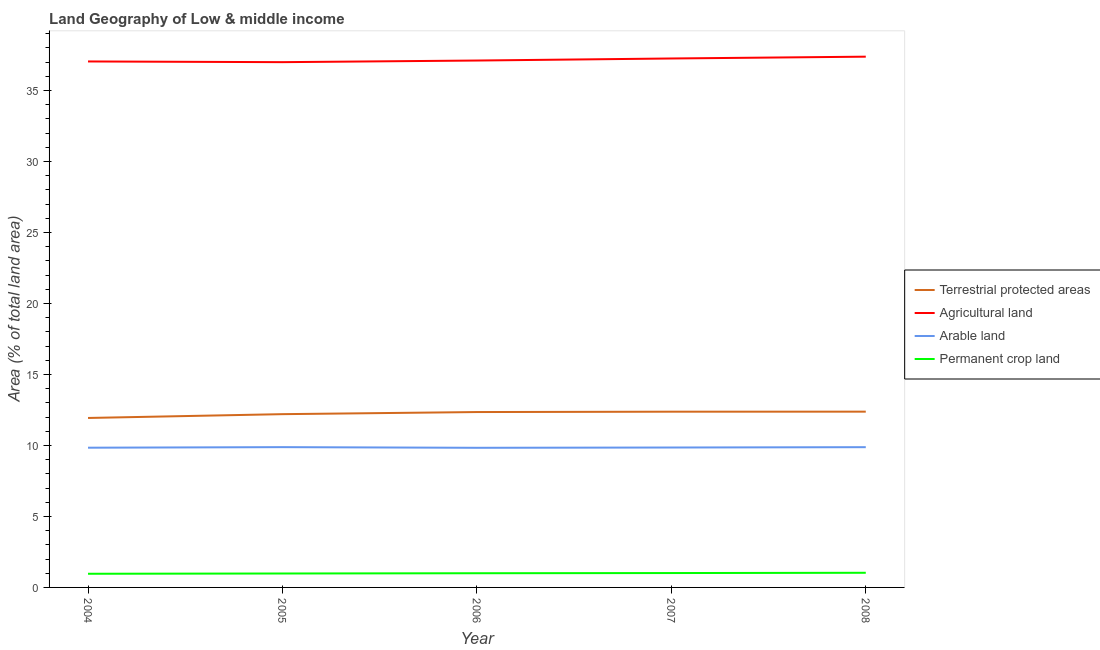How many different coloured lines are there?
Provide a short and direct response. 4. What is the percentage of area under permanent crop land in 2005?
Give a very brief answer. 0.98. Across all years, what is the maximum percentage of area under agricultural land?
Keep it short and to the point. 37.38. Across all years, what is the minimum percentage of area under agricultural land?
Give a very brief answer. 36.99. In which year was the percentage of land under terrestrial protection maximum?
Offer a very short reply. 2008. In which year was the percentage of area under agricultural land minimum?
Your answer should be compact. 2005. What is the total percentage of area under permanent crop land in the graph?
Your answer should be compact. 4.99. What is the difference between the percentage of area under permanent crop land in 2004 and that in 2008?
Ensure brevity in your answer.  -0.07. What is the difference between the percentage of area under agricultural land in 2004 and the percentage of area under arable land in 2005?
Provide a short and direct response. 27.16. What is the average percentage of area under agricultural land per year?
Your answer should be compact. 37.15. In the year 2005, what is the difference between the percentage of area under permanent crop land and percentage of area under arable land?
Make the answer very short. -8.9. In how many years, is the percentage of area under arable land greater than 27 %?
Keep it short and to the point. 0. What is the ratio of the percentage of area under arable land in 2005 to that in 2007?
Your answer should be very brief. 1. Is the percentage of area under agricultural land in 2005 less than that in 2007?
Offer a terse response. Yes. Is the difference between the percentage of land under terrestrial protection in 2004 and 2008 greater than the difference between the percentage of area under permanent crop land in 2004 and 2008?
Offer a very short reply. No. What is the difference between the highest and the second highest percentage of area under arable land?
Your answer should be compact. 0. What is the difference between the highest and the lowest percentage of area under agricultural land?
Keep it short and to the point. 0.39. Is it the case that in every year, the sum of the percentage of area under agricultural land and percentage of land under terrestrial protection is greater than the sum of percentage of area under permanent crop land and percentage of area under arable land?
Your answer should be very brief. Yes. Is it the case that in every year, the sum of the percentage of land under terrestrial protection and percentage of area under agricultural land is greater than the percentage of area under arable land?
Offer a very short reply. Yes. Does the percentage of area under arable land monotonically increase over the years?
Offer a terse response. No. Is the percentage of area under permanent crop land strictly less than the percentage of area under arable land over the years?
Give a very brief answer. Yes. Are the values on the major ticks of Y-axis written in scientific E-notation?
Ensure brevity in your answer.  No. Does the graph contain any zero values?
Make the answer very short. No. What is the title of the graph?
Offer a very short reply. Land Geography of Low & middle income. Does "Payroll services" appear as one of the legend labels in the graph?
Give a very brief answer. No. What is the label or title of the X-axis?
Your answer should be compact. Year. What is the label or title of the Y-axis?
Your response must be concise. Area (% of total land area). What is the Area (% of total land area) of Terrestrial protected areas in 2004?
Keep it short and to the point. 11.93. What is the Area (% of total land area) in Agricultural land in 2004?
Your answer should be compact. 37.04. What is the Area (% of total land area) in Arable land in 2004?
Your response must be concise. 9.84. What is the Area (% of total land area) in Permanent crop land in 2004?
Offer a very short reply. 0.96. What is the Area (% of total land area) of Terrestrial protected areas in 2005?
Provide a succinct answer. 12.2. What is the Area (% of total land area) of Agricultural land in 2005?
Give a very brief answer. 36.99. What is the Area (% of total land area) of Arable land in 2005?
Offer a very short reply. 9.88. What is the Area (% of total land area) of Permanent crop land in 2005?
Your response must be concise. 0.98. What is the Area (% of total land area) in Terrestrial protected areas in 2006?
Provide a succinct answer. 12.35. What is the Area (% of total land area) of Agricultural land in 2006?
Make the answer very short. 37.11. What is the Area (% of total land area) of Arable land in 2006?
Make the answer very short. 9.83. What is the Area (% of total land area) in Permanent crop land in 2006?
Make the answer very short. 1. What is the Area (% of total land area) of Terrestrial protected areas in 2007?
Your response must be concise. 12.38. What is the Area (% of total land area) in Agricultural land in 2007?
Give a very brief answer. 37.25. What is the Area (% of total land area) in Arable land in 2007?
Provide a short and direct response. 9.85. What is the Area (% of total land area) of Permanent crop land in 2007?
Provide a succinct answer. 1.01. What is the Area (% of total land area) of Terrestrial protected areas in 2008?
Keep it short and to the point. 12.38. What is the Area (% of total land area) of Agricultural land in 2008?
Provide a short and direct response. 37.38. What is the Area (% of total land area) in Arable land in 2008?
Your response must be concise. 9.88. What is the Area (% of total land area) of Permanent crop land in 2008?
Offer a terse response. 1.03. Across all years, what is the maximum Area (% of total land area) in Terrestrial protected areas?
Provide a short and direct response. 12.38. Across all years, what is the maximum Area (% of total land area) in Agricultural land?
Offer a very short reply. 37.38. Across all years, what is the maximum Area (% of total land area) in Arable land?
Offer a terse response. 9.88. Across all years, what is the maximum Area (% of total land area) of Permanent crop land?
Ensure brevity in your answer.  1.03. Across all years, what is the minimum Area (% of total land area) of Terrestrial protected areas?
Your answer should be very brief. 11.93. Across all years, what is the minimum Area (% of total land area) of Agricultural land?
Offer a very short reply. 36.99. Across all years, what is the minimum Area (% of total land area) in Arable land?
Make the answer very short. 9.83. Across all years, what is the minimum Area (% of total land area) in Permanent crop land?
Provide a succinct answer. 0.96. What is the total Area (% of total land area) of Terrestrial protected areas in the graph?
Ensure brevity in your answer.  61.24. What is the total Area (% of total land area) of Agricultural land in the graph?
Make the answer very short. 185.77. What is the total Area (% of total land area) of Arable land in the graph?
Offer a very short reply. 49.28. What is the total Area (% of total land area) in Permanent crop land in the graph?
Your response must be concise. 4.99. What is the difference between the Area (% of total land area) in Terrestrial protected areas in 2004 and that in 2005?
Make the answer very short. -0.27. What is the difference between the Area (% of total land area) of Agricultural land in 2004 and that in 2005?
Keep it short and to the point. 0.05. What is the difference between the Area (% of total land area) in Arable land in 2004 and that in 2005?
Keep it short and to the point. -0.04. What is the difference between the Area (% of total land area) in Permanent crop land in 2004 and that in 2005?
Provide a short and direct response. -0.02. What is the difference between the Area (% of total land area) in Terrestrial protected areas in 2004 and that in 2006?
Your answer should be compact. -0.42. What is the difference between the Area (% of total land area) in Agricultural land in 2004 and that in 2006?
Provide a succinct answer. -0.07. What is the difference between the Area (% of total land area) of Arable land in 2004 and that in 2006?
Give a very brief answer. 0.01. What is the difference between the Area (% of total land area) in Permanent crop land in 2004 and that in 2006?
Give a very brief answer. -0.04. What is the difference between the Area (% of total land area) in Terrestrial protected areas in 2004 and that in 2007?
Offer a very short reply. -0.44. What is the difference between the Area (% of total land area) in Agricultural land in 2004 and that in 2007?
Give a very brief answer. -0.21. What is the difference between the Area (% of total land area) of Arable land in 2004 and that in 2007?
Make the answer very short. -0.01. What is the difference between the Area (% of total land area) in Permanent crop land in 2004 and that in 2007?
Offer a very short reply. -0.05. What is the difference between the Area (% of total land area) of Terrestrial protected areas in 2004 and that in 2008?
Your answer should be very brief. -0.44. What is the difference between the Area (% of total land area) in Agricultural land in 2004 and that in 2008?
Provide a succinct answer. -0.34. What is the difference between the Area (% of total land area) of Arable land in 2004 and that in 2008?
Ensure brevity in your answer.  -0.04. What is the difference between the Area (% of total land area) of Permanent crop land in 2004 and that in 2008?
Your answer should be compact. -0.07. What is the difference between the Area (% of total land area) in Terrestrial protected areas in 2005 and that in 2006?
Keep it short and to the point. -0.15. What is the difference between the Area (% of total land area) of Agricultural land in 2005 and that in 2006?
Provide a succinct answer. -0.11. What is the difference between the Area (% of total land area) in Arable land in 2005 and that in 2006?
Your answer should be compact. 0.05. What is the difference between the Area (% of total land area) in Permanent crop land in 2005 and that in 2006?
Provide a succinct answer. -0.02. What is the difference between the Area (% of total land area) in Terrestrial protected areas in 2005 and that in 2007?
Offer a terse response. -0.17. What is the difference between the Area (% of total land area) of Agricultural land in 2005 and that in 2007?
Make the answer very short. -0.26. What is the difference between the Area (% of total land area) of Arable land in 2005 and that in 2007?
Give a very brief answer. 0.03. What is the difference between the Area (% of total land area) of Permanent crop land in 2005 and that in 2007?
Make the answer very short. -0.03. What is the difference between the Area (% of total land area) of Terrestrial protected areas in 2005 and that in 2008?
Your answer should be very brief. -0.18. What is the difference between the Area (% of total land area) in Agricultural land in 2005 and that in 2008?
Make the answer very short. -0.39. What is the difference between the Area (% of total land area) in Arable land in 2005 and that in 2008?
Provide a succinct answer. 0. What is the difference between the Area (% of total land area) in Permanent crop land in 2005 and that in 2008?
Your answer should be very brief. -0.05. What is the difference between the Area (% of total land area) in Terrestrial protected areas in 2006 and that in 2007?
Ensure brevity in your answer.  -0.02. What is the difference between the Area (% of total land area) in Agricultural land in 2006 and that in 2007?
Offer a terse response. -0.14. What is the difference between the Area (% of total land area) of Arable land in 2006 and that in 2007?
Make the answer very short. -0.02. What is the difference between the Area (% of total land area) in Permanent crop land in 2006 and that in 2007?
Your answer should be compact. -0.01. What is the difference between the Area (% of total land area) of Terrestrial protected areas in 2006 and that in 2008?
Your answer should be compact. -0.03. What is the difference between the Area (% of total land area) in Agricultural land in 2006 and that in 2008?
Provide a short and direct response. -0.27. What is the difference between the Area (% of total land area) in Arable land in 2006 and that in 2008?
Provide a succinct answer. -0.04. What is the difference between the Area (% of total land area) of Permanent crop land in 2006 and that in 2008?
Offer a terse response. -0.03. What is the difference between the Area (% of total land area) of Terrestrial protected areas in 2007 and that in 2008?
Provide a succinct answer. -0. What is the difference between the Area (% of total land area) of Agricultural land in 2007 and that in 2008?
Ensure brevity in your answer.  -0.13. What is the difference between the Area (% of total land area) in Arable land in 2007 and that in 2008?
Your answer should be very brief. -0.02. What is the difference between the Area (% of total land area) in Permanent crop land in 2007 and that in 2008?
Offer a very short reply. -0.02. What is the difference between the Area (% of total land area) of Terrestrial protected areas in 2004 and the Area (% of total land area) of Agricultural land in 2005?
Provide a short and direct response. -25.06. What is the difference between the Area (% of total land area) in Terrestrial protected areas in 2004 and the Area (% of total land area) in Arable land in 2005?
Your answer should be compact. 2.05. What is the difference between the Area (% of total land area) in Terrestrial protected areas in 2004 and the Area (% of total land area) in Permanent crop land in 2005?
Ensure brevity in your answer.  10.95. What is the difference between the Area (% of total land area) in Agricultural land in 2004 and the Area (% of total land area) in Arable land in 2005?
Offer a very short reply. 27.16. What is the difference between the Area (% of total land area) of Agricultural land in 2004 and the Area (% of total land area) of Permanent crop land in 2005?
Ensure brevity in your answer.  36.06. What is the difference between the Area (% of total land area) of Arable land in 2004 and the Area (% of total land area) of Permanent crop land in 2005?
Your response must be concise. 8.86. What is the difference between the Area (% of total land area) of Terrestrial protected areas in 2004 and the Area (% of total land area) of Agricultural land in 2006?
Provide a succinct answer. -25.17. What is the difference between the Area (% of total land area) of Terrestrial protected areas in 2004 and the Area (% of total land area) of Arable land in 2006?
Offer a terse response. 2.1. What is the difference between the Area (% of total land area) in Terrestrial protected areas in 2004 and the Area (% of total land area) in Permanent crop land in 2006?
Make the answer very short. 10.93. What is the difference between the Area (% of total land area) of Agricultural land in 2004 and the Area (% of total land area) of Arable land in 2006?
Make the answer very short. 27.21. What is the difference between the Area (% of total land area) of Agricultural land in 2004 and the Area (% of total land area) of Permanent crop land in 2006?
Ensure brevity in your answer.  36.04. What is the difference between the Area (% of total land area) in Arable land in 2004 and the Area (% of total land area) in Permanent crop land in 2006?
Provide a succinct answer. 8.84. What is the difference between the Area (% of total land area) in Terrestrial protected areas in 2004 and the Area (% of total land area) in Agricultural land in 2007?
Give a very brief answer. -25.32. What is the difference between the Area (% of total land area) in Terrestrial protected areas in 2004 and the Area (% of total land area) in Arable land in 2007?
Offer a very short reply. 2.08. What is the difference between the Area (% of total land area) in Terrestrial protected areas in 2004 and the Area (% of total land area) in Permanent crop land in 2007?
Make the answer very short. 10.92. What is the difference between the Area (% of total land area) of Agricultural land in 2004 and the Area (% of total land area) of Arable land in 2007?
Provide a short and direct response. 27.19. What is the difference between the Area (% of total land area) in Agricultural land in 2004 and the Area (% of total land area) in Permanent crop land in 2007?
Make the answer very short. 36.03. What is the difference between the Area (% of total land area) of Arable land in 2004 and the Area (% of total land area) of Permanent crop land in 2007?
Offer a terse response. 8.83. What is the difference between the Area (% of total land area) of Terrestrial protected areas in 2004 and the Area (% of total land area) of Agricultural land in 2008?
Your answer should be very brief. -25.44. What is the difference between the Area (% of total land area) in Terrestrial protected areas in 2004 and the Area (% of total land area) in Arable land in 2008?
Your answer should be very brief. 2.06. What is the difference between the Area (% of total land area) of Terrestrial protected areas in 2004 and the Area (% of total land area) of Permanent crop land in 2008?
Provide a short and direct response. 10.9. What is the difference between the Area (% of total land area) in Agricultural land in 2004 and the Area (% of total land area) in Arable land in 2008?
Your answer should be very brief. 27.16. What is the difference between the Area (% of total land area) of Agricultural land in 2004 and the Area (% of total land area) of Permanent crop land in 2008?
Your answer should be compact. 36.01. What is the difference between the Area (% of total land area) of Arable land in 2004 and the Area (% of total land area) of Permanent crop land in 2008?
Offer a terse response. 8.81. What is the difference between the Area (% of total land area) of Terrestrial protected areas in 2005 and the Area (% of total land area) of Agricultural land in 2006?
Ensure brevity in your answer.  -24.9. What is the difference between the Area (% of total land area) of Terrestrial protected areas in 2005 and the Area (% of total land area) of Arable land in 2006?
Keep it short and to the point. 2.37. What is the difference between the Area (% of total land area) of Terrestrial protected areas in 2005 and the Area (% of total land area) of Permanent crop land in 2006?
Offer a terse response. 11.2. What is the difference between the Area (% of total land area) in Agricultural land in 2005 and the Area (% of total land area) in Arable land in 2006?
Provide a short and direct response. 27.16. What is the difference between the Area (% of total land area) in Agricultural land in 2005 and the Area (% of total land area) in Permanent crop land in 2006?
Give a very brief answer. 35.99. What is the difference between the Area (% of total land area) in Arable land in 2005 and the Area (% of total land area) in Permanent crop land in 2006?
Keep it short and to the point. 8.88. What is the difference between the Area (% of total land area) in Terrestrial protected areas in 2005 and the Area (% of total land area) in Agricultural land in 2007?
Provide a short and direct response. -25.05. What is the difference between the Area (% of total land area) in Terrestrial protected areas in 2005 and the Area (% of total land area) in Arable land in 2007?
Offer a very short reply. 2.35. What is the difference between the Area (% of total land area) in Terrestrial protected areas in 2005 and the Area (% of total land area) in Permanent crop land in 2007?
Provide a succinct answer. 11.19. What is the difference between the Area (% of total land area) of Agricultural land in 2005 and the Area (% of total land area) of Arable land in 2007?
Offer a terse response. 27.14. What is the difference between the Area (% of total land area) of Agricultural land in 2005 and the Area (% of total land area) of Permanent crop land in 2007?
Make the answer very short. 35.98. What is the difference between the Area (% of total land area) in Arable land in 2005 and the Area (% of total land area) in Permanent crop land in 2007?
Offer a terse response. 8.87. What is the difference between the Area (% of total land area) in Terrestrial protected areas in 2005 and the Area (% of total land area) in Agricultural land in 2008?
Your response must be concise. -25.18. What is the difference between the Area (% of total land area) in Terrestrial protected areas in 2005 and the Area (% of total land area) in Arable land in 2008?
Ensure brevity in your answer.  2.33. What is the difference between the Area (% of total land area) in Terrestrial protected areas in 2005 and the Area (% of total land area) in Permanent crop land in 2008?
Your response must be concise. 11.17. What is the difference between the Area (% of total land area) in Agricultural land in 2005 and the Area (% of total land area) in Arable land in 2008?
Provide a succinct answer. 27.12. What is the difference between the Area (% of total land area) in Agricultural land in 2005 and the Area (% of total land area) in Permanent crop land in 2008?
Your answer should be very brief. 35.96. What is the difference between the Area (% of total land area) of Arable land in 2005 and the Area (% of total land area) of Permanent crop land in 2008?
Provide a short and direct response. 8.85. What is the difference between the Area (% of total land area) in Terrestrial protected areas in 2006 and the Area (% of total land area) in Agricultural land in 2007?
Your answer should be very brief. -24.9. What is the difference between the Area (% of total land area) of Terrestrial protected areas in 2006 and the Area (% of total land area) of Arable land in 2007?
Your answer should be compact. 2.5. What is the difference between the Area (% of total land area) in Terrestrial protected areas in 2006 and the Area (% of total land area) in Permanent crop land in 2007?
Offer a very short reply. 11.34. What is the difference between the Area (% of total land area) in Agricultural land in 2006 and the Area (% of total land area) in Arable land in 2007?
Make the answer very short. 27.25. What is the difference between the Area (% of total land area) of Agricultural land in 2006 and the Area (% of total land area) of Permanent crop land in 2007?
Offer a terse response. 36.09. What is the difference between the Area (% of total land area) in Arable land in 2006 and the Area (% of total land area) in Permanent crop land in 2007?
Provide a succinct answer. 8.82. What is the difference between the Area (% of total land area) in Terrestrial protected areas in 2006 and the Area (% of total land area) in Agricultural land in 2008?
Offer a terse response. -25.03. What is the difference between the Area (% of total land area) of Terrestrial protected areas in 2006 and the Area (% of total land area) of Arable land in 2008?
Offer a very short reply. 2.47. What is the difference between the Area (% of total land area) in Terrestrial protected areas in 2006 and the Area (% of total land area) in Permanent crop land in 2008?
Offer a terse response. 11.32. What is the difference between the Area (% of total land area) of Agricultural land in 2006 and the Area (% of total land area) of Arable land in 2008?
Provide a short and direct response. 27.23. What is the difference between the Area (% of total land area) of Agricultural land in 2006 and the Area (% of total land area) of Permanent crop land in 2008?
Your answer should be compact. 36.08. What is the difference between the Area (% of total land area) of Arable land in 2006 and the Area (% of total land area) of Permanent crop land in 2008?
Your response must be concise. 8.8. What is the difference between the Area (% of total land area) of Terrestrial protected areas in 2007 and the Area (% of total land area) of Agricultural land in 2008?
Offer a terse response. -25. What is the difference between the Area (% of total land area) in Terrestrial protected areas in 2007 and the Area (% of total land area) in Arable land in 2008?
Offer a very short reply. 2.5. What is the difference between the Area (% of total land area) of Terrestrial protected areas in 2007 and the Area (% of total land area) of Permanent crop land in 2008?
Offer a very short reply. 11.34. What is the difference between the Area (% of total land area) of Agricultural land in 2007 and the Area (% of total land area) of Arable land in 2008?
Make the answer very short. 27.37. What is the difference between the Area (% of total land area) of Agricultural land in 2007 and the Area (% of total land area) of Permanent crop land in 2008?
Make the answer very short. 36.22. What is the difference between the Area (% of total land area) in Arable land in 2007 and the Area (% of total land area) in Permanent crop land in 2008?
Your answer should be compact. 8.82. What is the average Area (% of total land area) of Terrestrial protected areas per year?
Keep it short and to the point. 12.25. What is the average Area (% of total land area) in Agricultural land per year?
Your answer should be compact. 37.15. What is the average Area (% of total land area) in Arable land per year?
Give a very brief answer. 9.86. What is the average Area (% of total land area) in Permanent crop land per year?
Keep it short and to the point. 1. In the year 2004, what is the difference between the Area (% of total land area) of Terrestrial protected areas and Area (% of total land area) of Agricultural land?
Your answer should be very brief. -25.11. In the year 2004, what is the difference between the Area (% of total land area) in Terrestrial protected areas and Area (% of total land area) in Arable land?
Keep it short and to the point. 2.09. In the year 2004, what is the difference between the Area (% of total land area) of Terrestrial protected areas and Area (% of total land area) of Permanent crop land?
Your response must be concise. 10.97. In the year 2004, what is the difference between the Area (% of total land area) in Agricultural land and Area (% of total land area) in Arable land?
Your answer should be very brief. 27.2. In the year 2004, what is the difference between the Area (% of total land area) in Agricultural land and Area (% of total land area) in Permanent crop land?
Offer a terse response. 36.08. In the year 2004, what is the difference between the Area (% of total land area) in Arable land and Area (% of total land area) in Permanent crop land?
Make the answer very short. 8.88. In the year 2005, what is the difference between the Area (% of total land area) in Terrestrial protected areas and Area (% of total land area) in Agricultural land?
Provide a short and direct response. -24.79. In the year 2005, what is the difference between the Area (% of total land area) of Terrestrial protected areas and Area (% of total land area) of Arable land?
Keep it short and to the point. 2.32. In the year 2005, what is the difference between the Area (% of total land area) of Terrestrial protected areas and Area (% of total land area) of Permanent crop land?
Your answer should be compact. 11.22. In the year 2005, what is the difference between the Area (% of total land area) in Agricultural land and Area (% of total land area) in Arable land?
Offer a very short reply. 27.11. In the year 2005, what is the difference between the Area (% of total land area) in Agricultural land and Area (% of total land area) in Permanent crop land?
Your answer should be very brief. 36.01. In the year 2005, what is the difference between the Area (% of total land area) of Arable land and Area (% of total land area) of Permanent crop land?
Make the answer very short. 8.9. In the year 2006, what is the difference between the Area (% of total land area) in Terrestrial protected areas and Area (% of total land area) in Agricultural land?
Your answer should be very brief. -24.76. In the year 2006, what is the difference between the Area (% of total land area) in Terrestrial protected areas and Area (% of total land area) in Arable land?
Offer a terse response. 2.52. In the year 2006, what is the difference between the Area (% of total land area) of Terrestrial protected areas and Area (% of total land area) of Permanent crop land?
Give a very brief answer. 11.35. In the year 2006, what is the difference between the Area (% of total land area) of Agricultural land and Area (% of total land area) of Arable land?
Your answer should be very brief. 27.27. In the year 2006, what is the difference between the Area (% of total land area) in Agricultural land and Area (% of total land area) in Permanent crop land?
Ensure brevity in your answer.  36.11. In the year 2006, what is the difference between the Area (% of total land area) in Arable land and Area (% of total land area) in Permanent crop land?
Provide a short and direct response. 8.83. In the year 2007, what is the difference between the Area (% of total land area) in Terrestrial protected areas and Area (% of total land area) in Agricultural land?
Provide a short and direct response. -24.87. In the year 2007, what is the difference between the Area (% of total land area) in Terrestrial protected areas and Area (% of total land area) in Arable land?
Offer a very short reply. 2.52. In the year 2007, what is the difference between the Area (% of total land area) in Terrestrial protected areas and Area (% of total land area) in Permanent crop land?
Make the answer very short. 11.36. In the year 2007, what is the difference between the Area (% of total land area) in Agricultural land and Area (% of total land area) in Arable land?
Ensure brevity in your answer.  27.4. In the year 2007, what is the difference between the Area (% of total land area) of Agricultural land and Area (% of total land area) of Permanent crop land?
Your response must be concise. 36.24. In the year 2007, what is the difference between the Area (% of total land area) of Arable land and Area (% of total land area) of Permanent crop land?
Give a very brief answer. 8.84. In the year 2008, what is the difference between the Area (% of total land area) in Terrestrial protected areas and Area (% of total land area) in Agricultural land?
Provide a short and direct response. -25. In the year 2008, what is the difference between the Area (% of total land area) of Terrestrial protected areas and Area (% of total land area) of Arable land?
Your answer should be very brief. 2.5. In the year 2008, what is the difference between the Area (% of total land area) in Terrestrial protected areas and Area (% of total land area) in Permanent crop land?
Provide a succinct answer. 11.35. In the year 2008, what is the difference between the Area (% of total land area) in Agricultural land and Area (% of total land area) in Arable land?
Your answer should be compact. 27.5. In the year 2008, what is the difference between the Area (% of total land area) of Agricultural land and Area (% of total land area) of Permanent crop land?
Keep it short and to the point. 36.35. In the year 2008, what is the difference between the Area (% of total land area) in Arable land and Area (% of total land area) in Permanent crop land?
Offer a terse response. 8.85. What is the ratio of the Area (% of total land area) of Agricultural land in 2004 to that in 2005?
Provide a short and direct response. 1. What is the ratio of the Area (% of total land area) in Arable land in 2004 to that in 2005?
Your answer should be very brief. 1. What is the ratio of the Area (% of total land area) in Permanent crop land in 2004 to that in 2005?
Make the answer very short. 0.98. What is the ratio of the Area (% of total land area) of Terrestrial protected areas in 2004 to that in 2006?
Your response must be concise. 0.97. What is the ratio of the Area (% of total land area) of Permanent crop land in 2004 to that in 2006?
Make the answer very short. 0.96. What is the ratio of the Area (% of total land area) in Terrestrial protected areas in 2004 to that in 2007?
Your answer should be very brief. 0.96. What is the ratio of the Area (% of total land area) of Agricultural land in 2004 to that in 2007?
Ensure brevity in your answer.  0.99. What is the ratio of the Area (% of total land area) of Arable land in 2004 to that in 2007?
Give a very brief answer. 1. What is the ratio of the Area (% of total land area) in Permanent crop land in 2004 to that in 2007?
Your response must be concise. 0.95. What is the ratio of the Area (% of total land area) in Terrestrial protected areas in 2004 to that in 2008?
Offer a very short reply. 0.96. What is the ratio of the Area (% of total land area) in Agricultural land in 2004 to that in 2008?
Keep it short and to the point. 0.99. What is the ratio of the Area (% of total land area) in Arable land in 2004 to that in 2008?
Give a very brief answer. 1. What is the ratio of the Area (% of total land area) of Permanent crop land in 2004 to that in 2008?
Make the answer very short. 0.93. What is the ratio of the Area (% of total land area) of Terrestrial protected areas in 2005 to that in 2006?
Offer a very short reply. 0.99. What is the ratio of the Area (% of total land area) in Agricultural land in 2005 to that in 2006?
Give a very brief answer. 1. What is the ratio of the Area (% of total land area) of Arable land in 2005 to that in 2006?
Keep it short and to the point. 1. What is the ratio of the Area (% of total land area) in Permanent crop land in 2005 to that in 2006?
Keep it short and to the point. 0.98. What is the ratio of the Area (% of total land area) of Terrestrial protected areas in 2005 to that in 2007?
Provide a short and direct response. 0.99. What is the ratio of the Area (% of total land area) in Arable land in 2005 to that in 2007?
Provide a short and direct response. 1. What is the ratio of the Area (% of total land area) in Permanent crop land in 2005 to that in 2007?
Your answer should be very brief. 0.97. What is the ratio of the Area (% of total land area) in Terrestrial protected areas in 2005 to that in 2008?
Make the answer very short. 0.99. What is the ratio of the Area (% of total land area) of Agricultural land in 2005 to that in 2008?
Offer a terse response. 0.99. What is the ratio of the Area (% of total land area) in Permanent crop land in 2005 to that in 2008?
Offer a very short reply. 0.95. What is the ratio of the Area (% of total land area) of Terrestrial protected areas in 2006 to that in 2007?
Provide a short and direct response. 1. What is the ratio of the Area (% of total land area) in Permanent crop land in 2006 to that in 2007?
Offer a terse response. 0.99. What is the ratio of the Area (% of total land area) in Terrestrial protected areas in 2006 to that in 2008?
Your answer should be compact. 1. What is the ratio of the Area (% of total land area) in Permanent crop land in 2006 to that in 2008?
Give a very brief answer. 0.97. What is the ratio of the Area (% of total land area) of Agricultural land in 2007 to that in 2008?
Provide a succinct answer. 1. What is the ratio of the Area (% of total land area) of Permanent crop land in 2007 to that in 2008?
Your response must be concise. 0.98. What is the difference between the highest and the second highest Area (% of total land area) in Terrestrial protected areas?
Give a very brief answer. 0. What is the difference between the highest and the second highest Area (% of total land area) of Agricultural land?
Offer a terse response. 0.13. What is the difference between the highest and the second highest Area (% of total land area) in Arable land?
Make the answer very short. 0. What is the difference between the highest and the second highest Area (% of total land area) of Permanent crop land?
Ensure brevity in your answer.  0.02. What is the difference between the highest and the lowest Area (% of total land area) of Terrestrial protected areas?
Give a very brief answer. 0.44. What is the difference between the highest and the lowest Area (% of total land area) in Agricultural land?
Provide a succinct answer. 0.39. What is the difference between the highest and the lowest Area (% of total land area) of Arable land?
Offer a terse response. 0.05. What is the difference between the highest and the lowest Area (% of total land area) of Permanent crop land?
Your answer should be very brief. 0.07. 